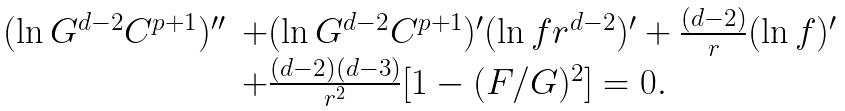<formula> <loc_0><loc_0><loc_500><loc_500>\begin{array} { l l } ( \ln G ^ { d - 2 } C ^ { p + 1 } ) ^ { \prime \prime } & + ( \ln G ^ { d - 2 } C ^ { p + 1 } ) ^ { \prime } ( \ln f r ^ { d - 2 } ) ^ { \prime } + \frac { ( d - 2 ) } { r } ( \ln f ) ^ { \prime } \\ & + \frac { ( d - 2 ) ( d - 3 ) } { r ^ { 2 } } [ 1 - ( { F } / { G } ) ^ { 2 } ] = 0 . \end{array}</formula> 